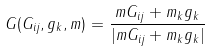Convert formula to latex. <formula><loc_0><loc_0><loc_500><loc_500>G ( G _ { i j } , g _ { k } , m ) = \frac { m G _ { i j } + m _ { k } g _ { k } } { | m G _ { i j } + m _ { k } g _ { k } | }</formula> 